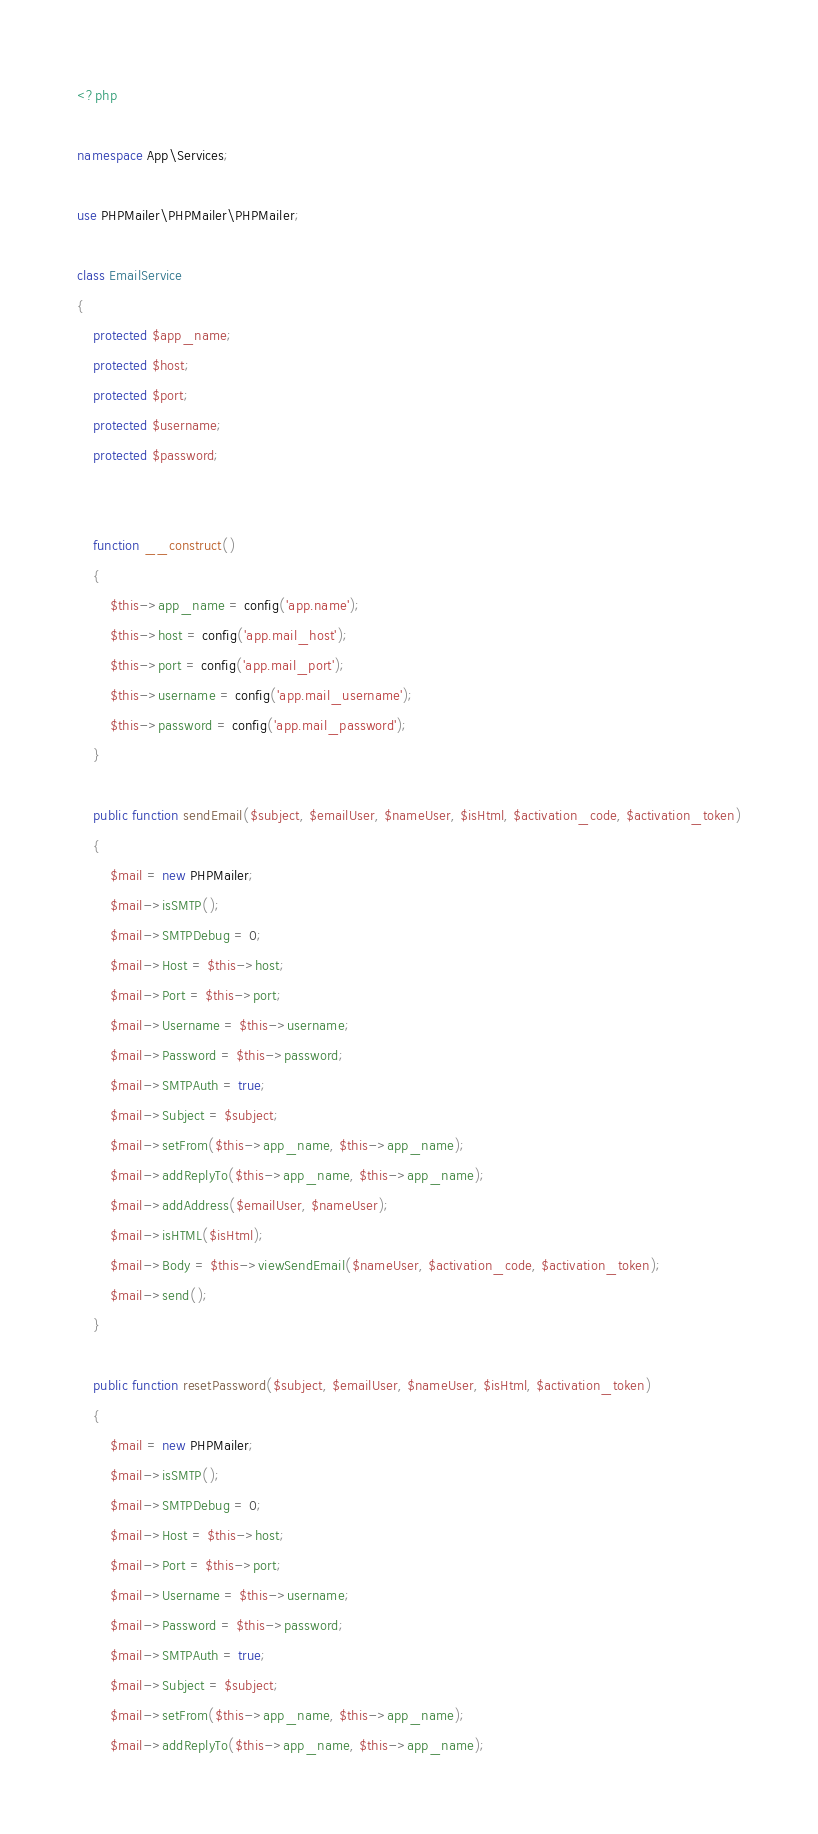Convert code to text. <code><loc_0><loc_0><loc_500><loc_500><_PHP_><?php

namespace App\Services;

use PHPMailer\PHPMailer\PHPMailer;

class EmailService
{
    protected $app_name;
    protected $host;
    protected $port;
    protected $username;
    protected $password;


    function __construct()
    {
        $this->app_name = config('app.name');
        $this->host = config('app.mail_host');
        $this->port = config('app.mail_port');
        $this->username = config('app.mail_username');
        $this->password = config('app.mail_password');
    }

    public function sendEmail($subject, $emailUser, $nameUser, $isHtml, $activation_code, $activation_token)
    {
        $mail = new PHPMailer;
        $mail->isSMTP();
        $mail->SMTPDebug = 0;
        $mail->Host = $this->host;
        $mail->Port = $this->port;
        $mail->Username = $this->username;
        $mail->Password = $this->password;
        $mail->SMTPAuth = true;
        $mail->Subject = $subject;
        $mail->setFrom($this->app_name, $this->app_name);
        $mail->addReplyTo($this->app_name, $this->app_name);
        $mail->addAddress($emailUser, $nameUser);
        $mail->isHTML($isHtml);
        $mail->Body = $this->viewSendEmail($nameUser, $activation_code, $activation_token);
        $mail->send();
    }

    public function resetPassword($subject, $emailUser, $nameUser, $isHtml, $activation_token)
    {
        $mail = new PHPMailer;
        $mail->isSMTP();
        $mail->SMTPDebug = 0;
        $mail->Host = $this->host;
        $mail->Port = $this->port;
        $mail->Username = $this->username;
        $mail->Password = $this->password;
        $mail->SMTPAuth = true;
        $mail->Subject = $subject;
        $mail->setFrom($this->app_name, $this->app_name);
        $mail->addReplyTo($this->app_name, $this->app_name);</code> 